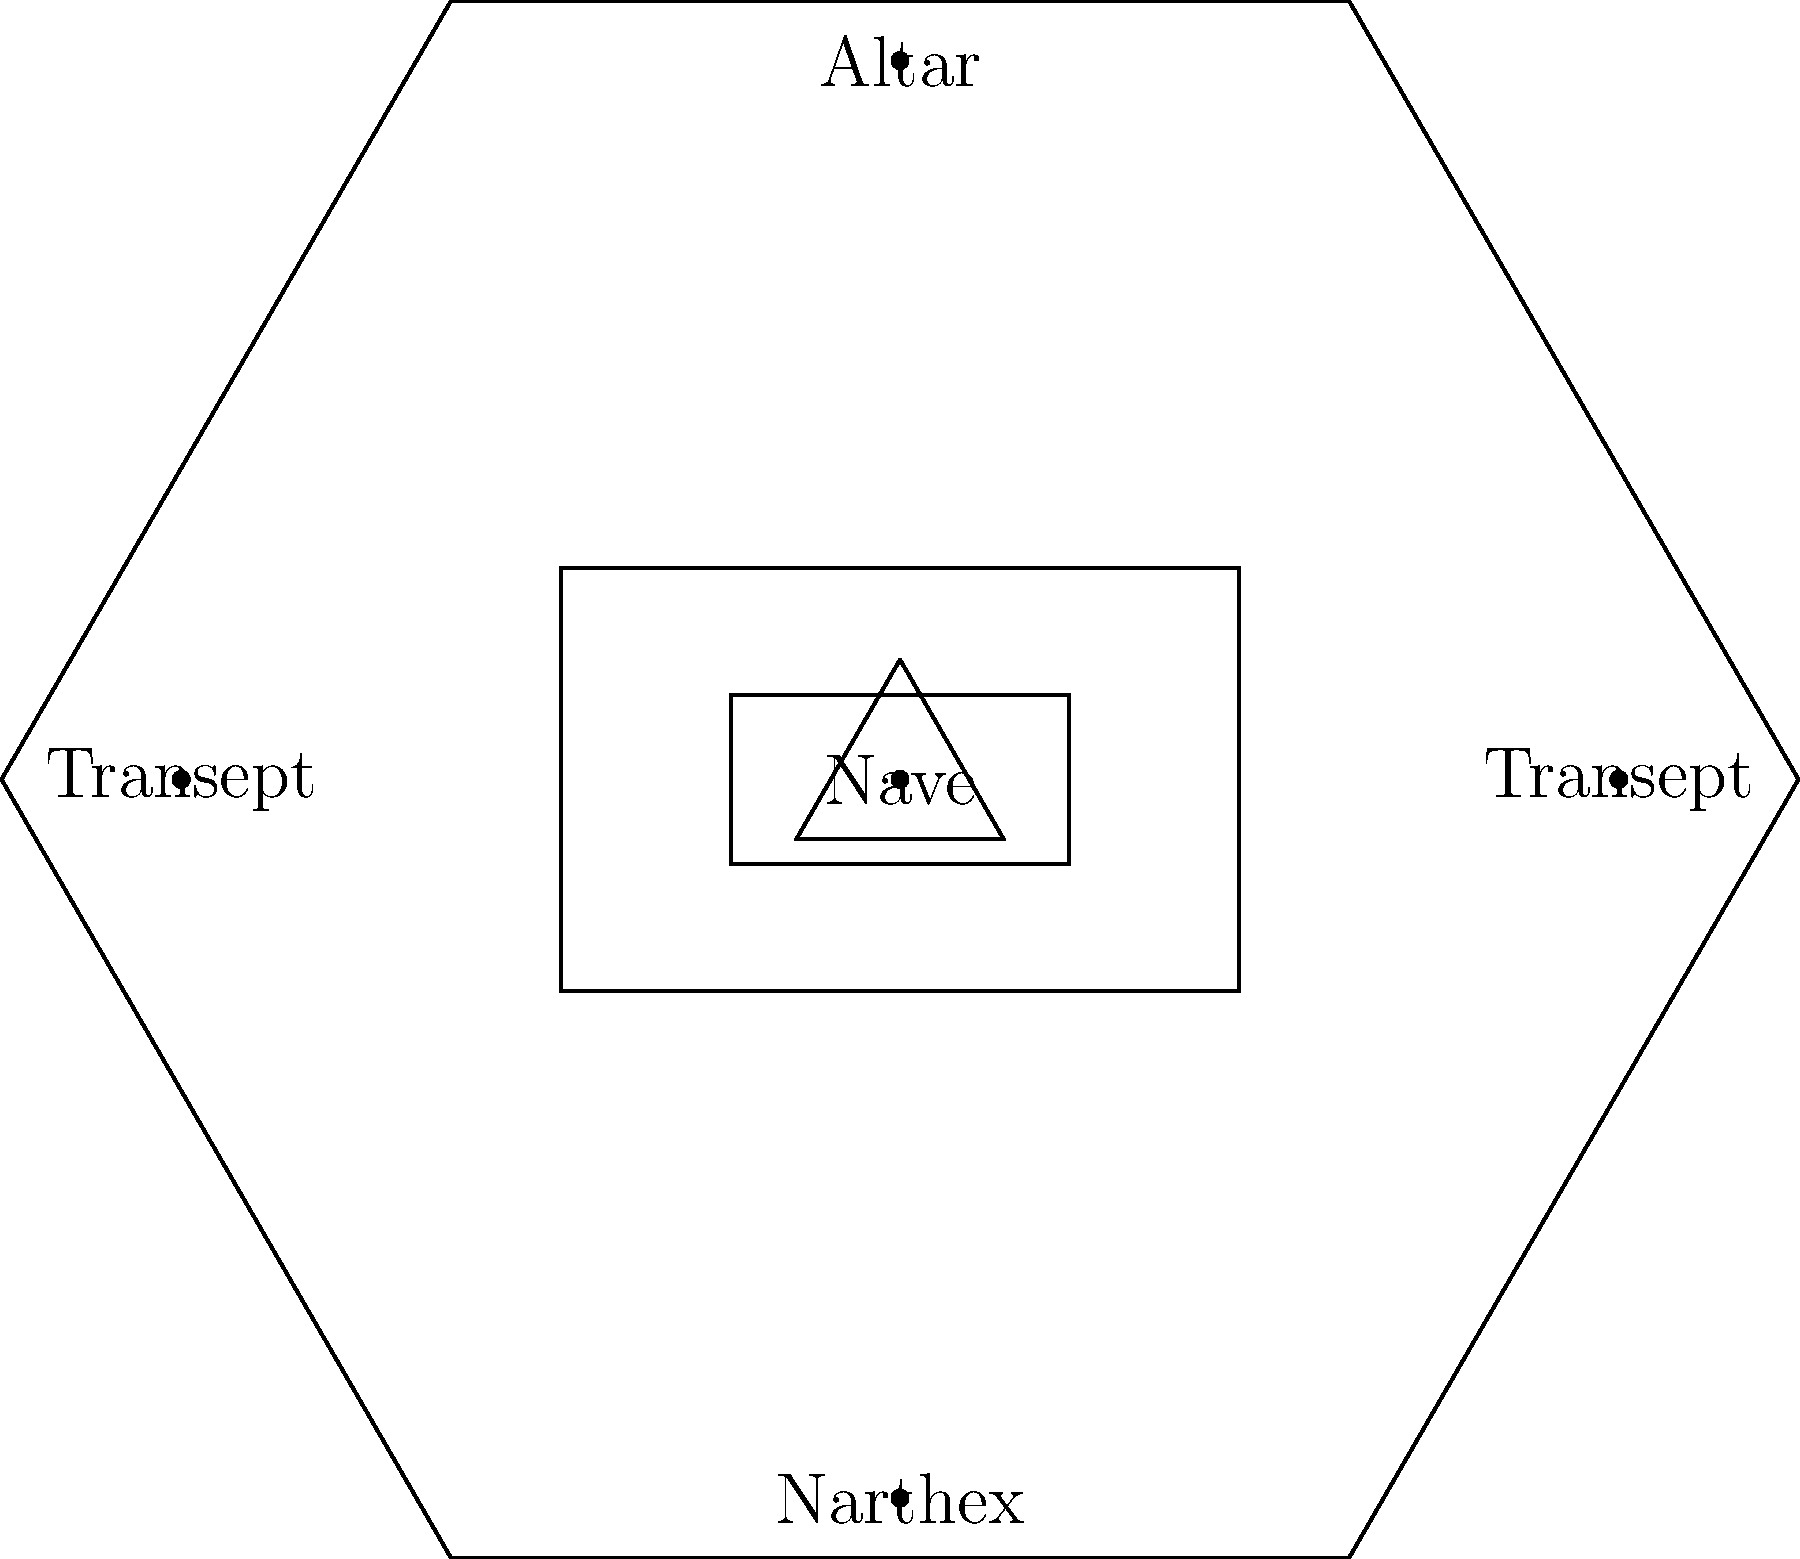In the typical church floor plan shown above, which area is traditionally considered the main body of the church where the congregation sits during services? To answer this question, let's examine the different parts of the church floor plan:

1. The altar is located at the top of the diagram, typically facing east. This is where the priest conducts the main parts of the service.

2. The narthex is at the bottom of the diagram, usually the entrance area of the church.

3. The transepts are the two areas extending to the left and right, forming a cross-shape when viewed from above.

4. The nave is the central, rectangular area between the narthex and the altar.

The nave is traditionally the main seating area for the congregation. It's the largest space in the church, designed to accommodate the majority of worshippers. This area allows the congregation to face the altar and participate in the service.
Answer: Nave 